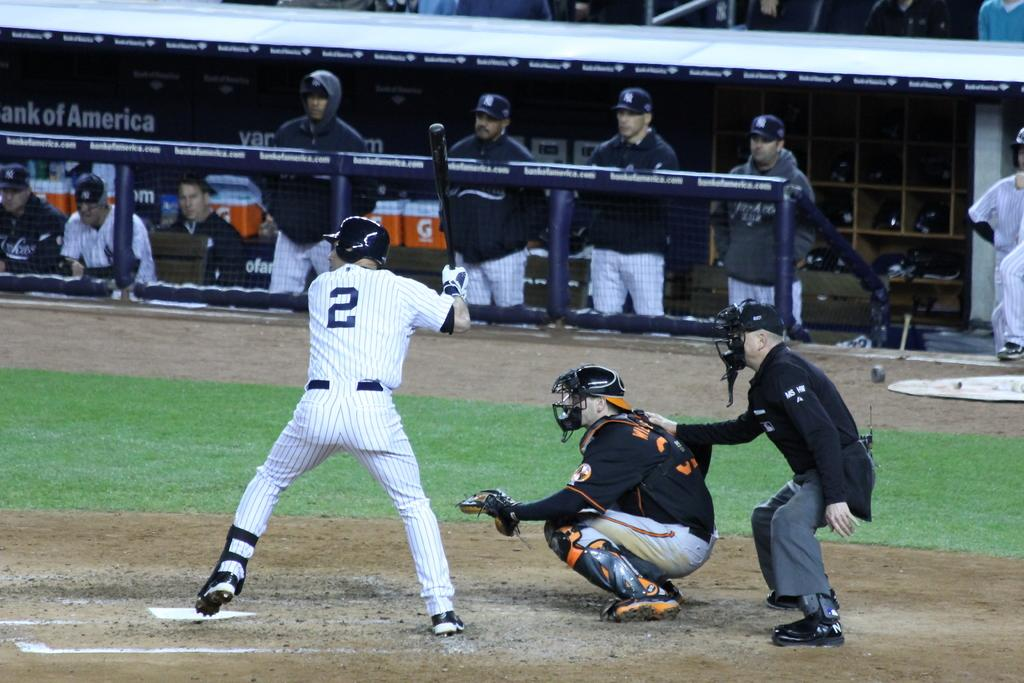<image>
Render a clear and concise summary of the photo. Above the dug out is a banner that reads Bank of America. 